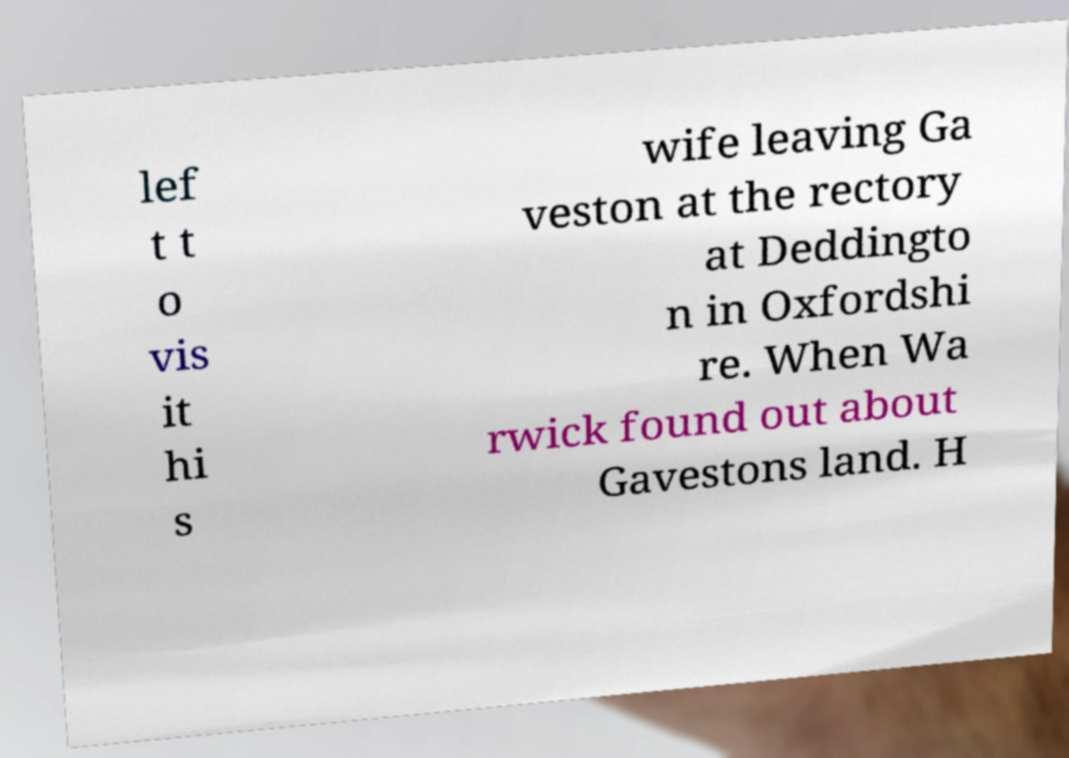There's text embedded in this image that I need extracted. Can you transcribe it verbatim? lef t t o vis it hi s wife leaving Ga veston at the rectory at Deddingto n in Oxfordshi re. When Wa rwick found out about Gavestons land. H 